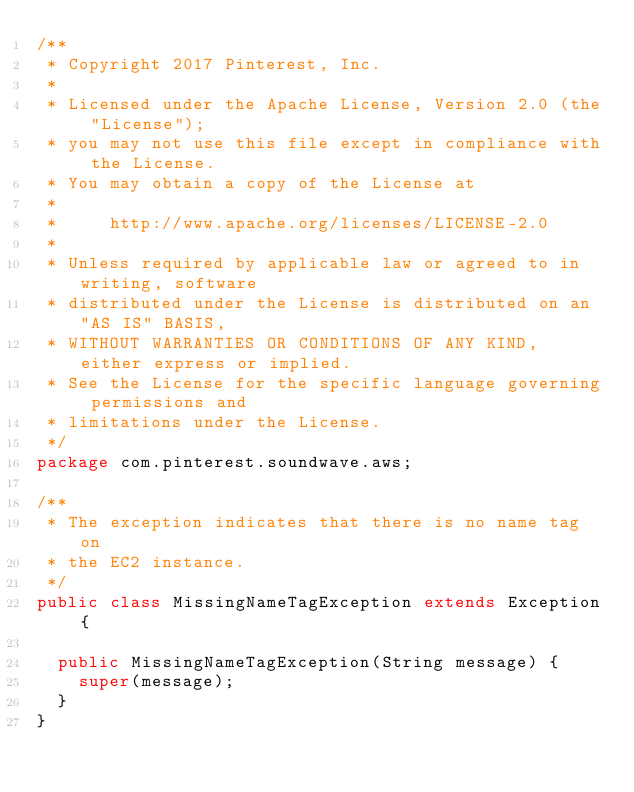Convert code to text. <code><loc_0><loc_0><loc_500><loc_500><_Java_>/**
 * Copyright 2017 Pinterest, Inc.
 *
 * Licensed under the Apache License, Version 2.0 (the "License");
 * you may not use this file except in compliance with the License.
 * You may obtain a copy of the License at
 *
 *     http://www.apache.org/licenses/LICENSE-2.0
 *
 * Unless required by applicable law or agreed to in writing, software
 * distributed under the License is distributed on an "AS IS" BASIS,
 * WITHOUT WARRANTIES OR CONDITIONS OF ANY KIND, either express or implied.
 * See the License for the specific language governing permissions and
 * limitations under the License.
 */
package com.pinterest.soundwave.aws;

/**
 * The exception indicates that there is no name tag on
 * the EC2 instance.
 */
public class MissingNameTagException extends Exception {

  public MissingNameTagException(String message) {
    super(message);
  }
}
</code> 